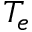Convert formula to latex. <formula><loc_0><loc_0><loc_500><loc_500>T _ { e }</formula> 